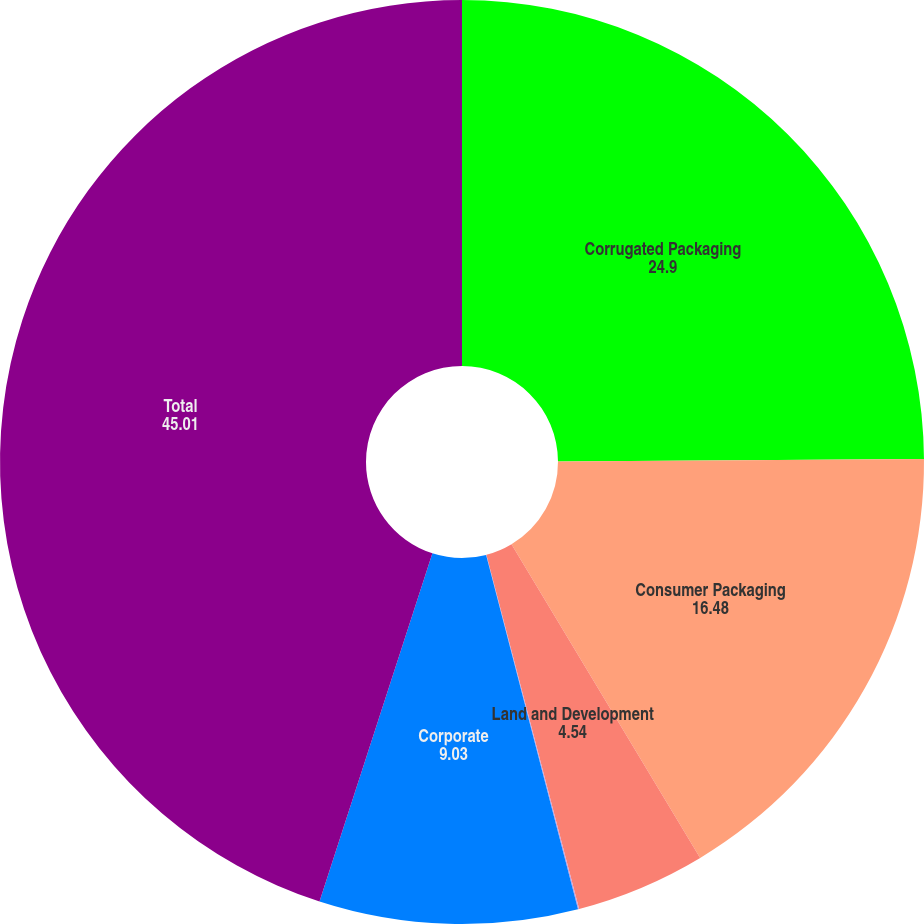Convert chart to OTSL. <chart><loc_0><loc_0><loc_500><loc_500><pie_chart><fcel>Corrugated Packaging<fcel>Consumer Packaging<fcel>Land and Development<fcel>Assets held for sale<fcel>Corporate<fcel>Total<nl><fcel>24.9%<fcel>16.48%<fcel>4.54%<fcel>0.04%<fcel>9.03%<fcel>45.01%<nl></chart> 